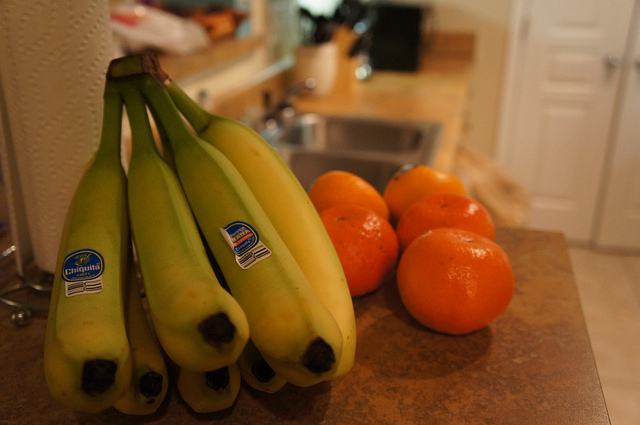What other fruits can be seen in the image besides the bananas? In addition to the bananas, there's a group of five vibrant orange fruits on the cutting board, which appear to be oranges or tangerines, also fresh and likely to be juicy. 